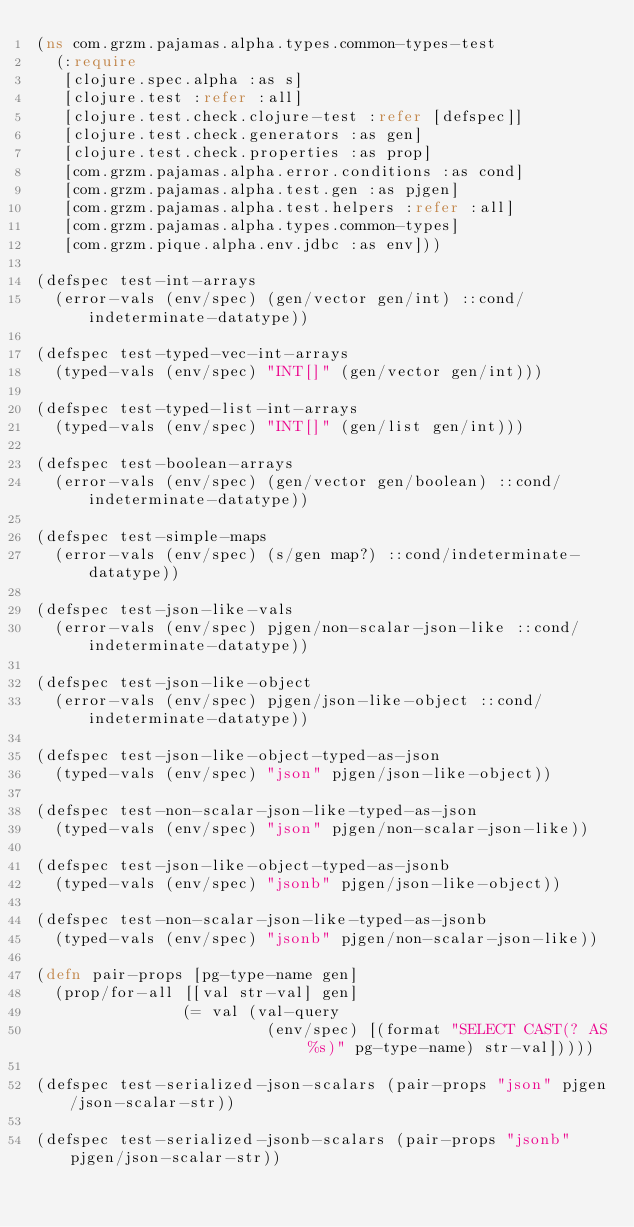Convert code to text. <code><loc_0><loc_0><loc_500><loc_500><_Clojure_>(ns com.grzm.pajamas.alpha.types.common-types-test
  (:require
   [clojure.spec.alpha :as s]
   [clojure.test :refer :all]
   [clojure.test.check.clojure-test :refer [defspec]]
   [clojure.test.check.generators :as gen]
   [clojure.test.check.properties :as prop]
   [com.grzm.pajamas.alpha.error.conditions :as cond]
   [com.grzm.pajamas.alpha.test.gen :as pjgen]
   [com.grzm.pajamas.alpha.test.helpers :refer :all]
   [com.grzm.pajamas.alpha.types.common-types]
   [com.grzm.pique.alpha.env.jdbc :as env]))

(defspec test-int-arrays
  (error-vals (env/spec) (gen/vector gen/int) ::cond/indeterminate-datatype))

(defspec test-typed-vec-int-arrays
  (typed-vals (env/spec) "INT[]" (gen/vector gen/int)))

(defspec test-typed-list-int-arrays
  (typed-vals (env/spec) "INT[]" (gen/list gen/int)))

(defspec test-boolean-arrays
  (error-vals (env/spec) (gen/vector gen/boolean) ::cond/indeterminate-datatype))

(defspec test-simple-maps
  (error-vals (env/spec) (s/gen map?) ::cond/indeterminate-datatype))

(defspec test-json-like-vals
  (error-vals (env/spec) pjgen/non-scalar-json-like ::cond/indeterminate-datatype))

(defspec test-json-like-object
  (error-vals (env/spec) pjgen/json-like-object ::cond/indeterminate-datatype))

(defspec test-json-like-object-typed-as-json
  (typed-vals (env/spec) "json" pjgen/json-like-object))

(defspec test-non-scalar-json-like-typed-as-json
  (typed-vals (env/spec) "json" pjgen/non-scalar-json-like))

(defspec test-json-like-object-typed-as-jsonb
  (typed-vals (env/spec) "jsonb" pjgen/json-like-object))

(defspec test-non-scalar-json-like-typed-as-jsonb
  (typed-vals (env/spec) "jsonb" pjgen/non-scalar-json-like))

(defn pair-props [pg-type-name gen]
  (prop/for-all [[val str-val] gen]
                (= val (val-query
                         (env/spec) [(format "SELECT CAST(? AS %s)" pg-type-name) str-val]))))

(defspec test-serialized-json-scalars (pair-props "json" pjgen/json-scalar-str))

(defspec test-serialized-jsonb-scalars (pair-props "jsonb" pjgen/json-scalar-str))

</code> 